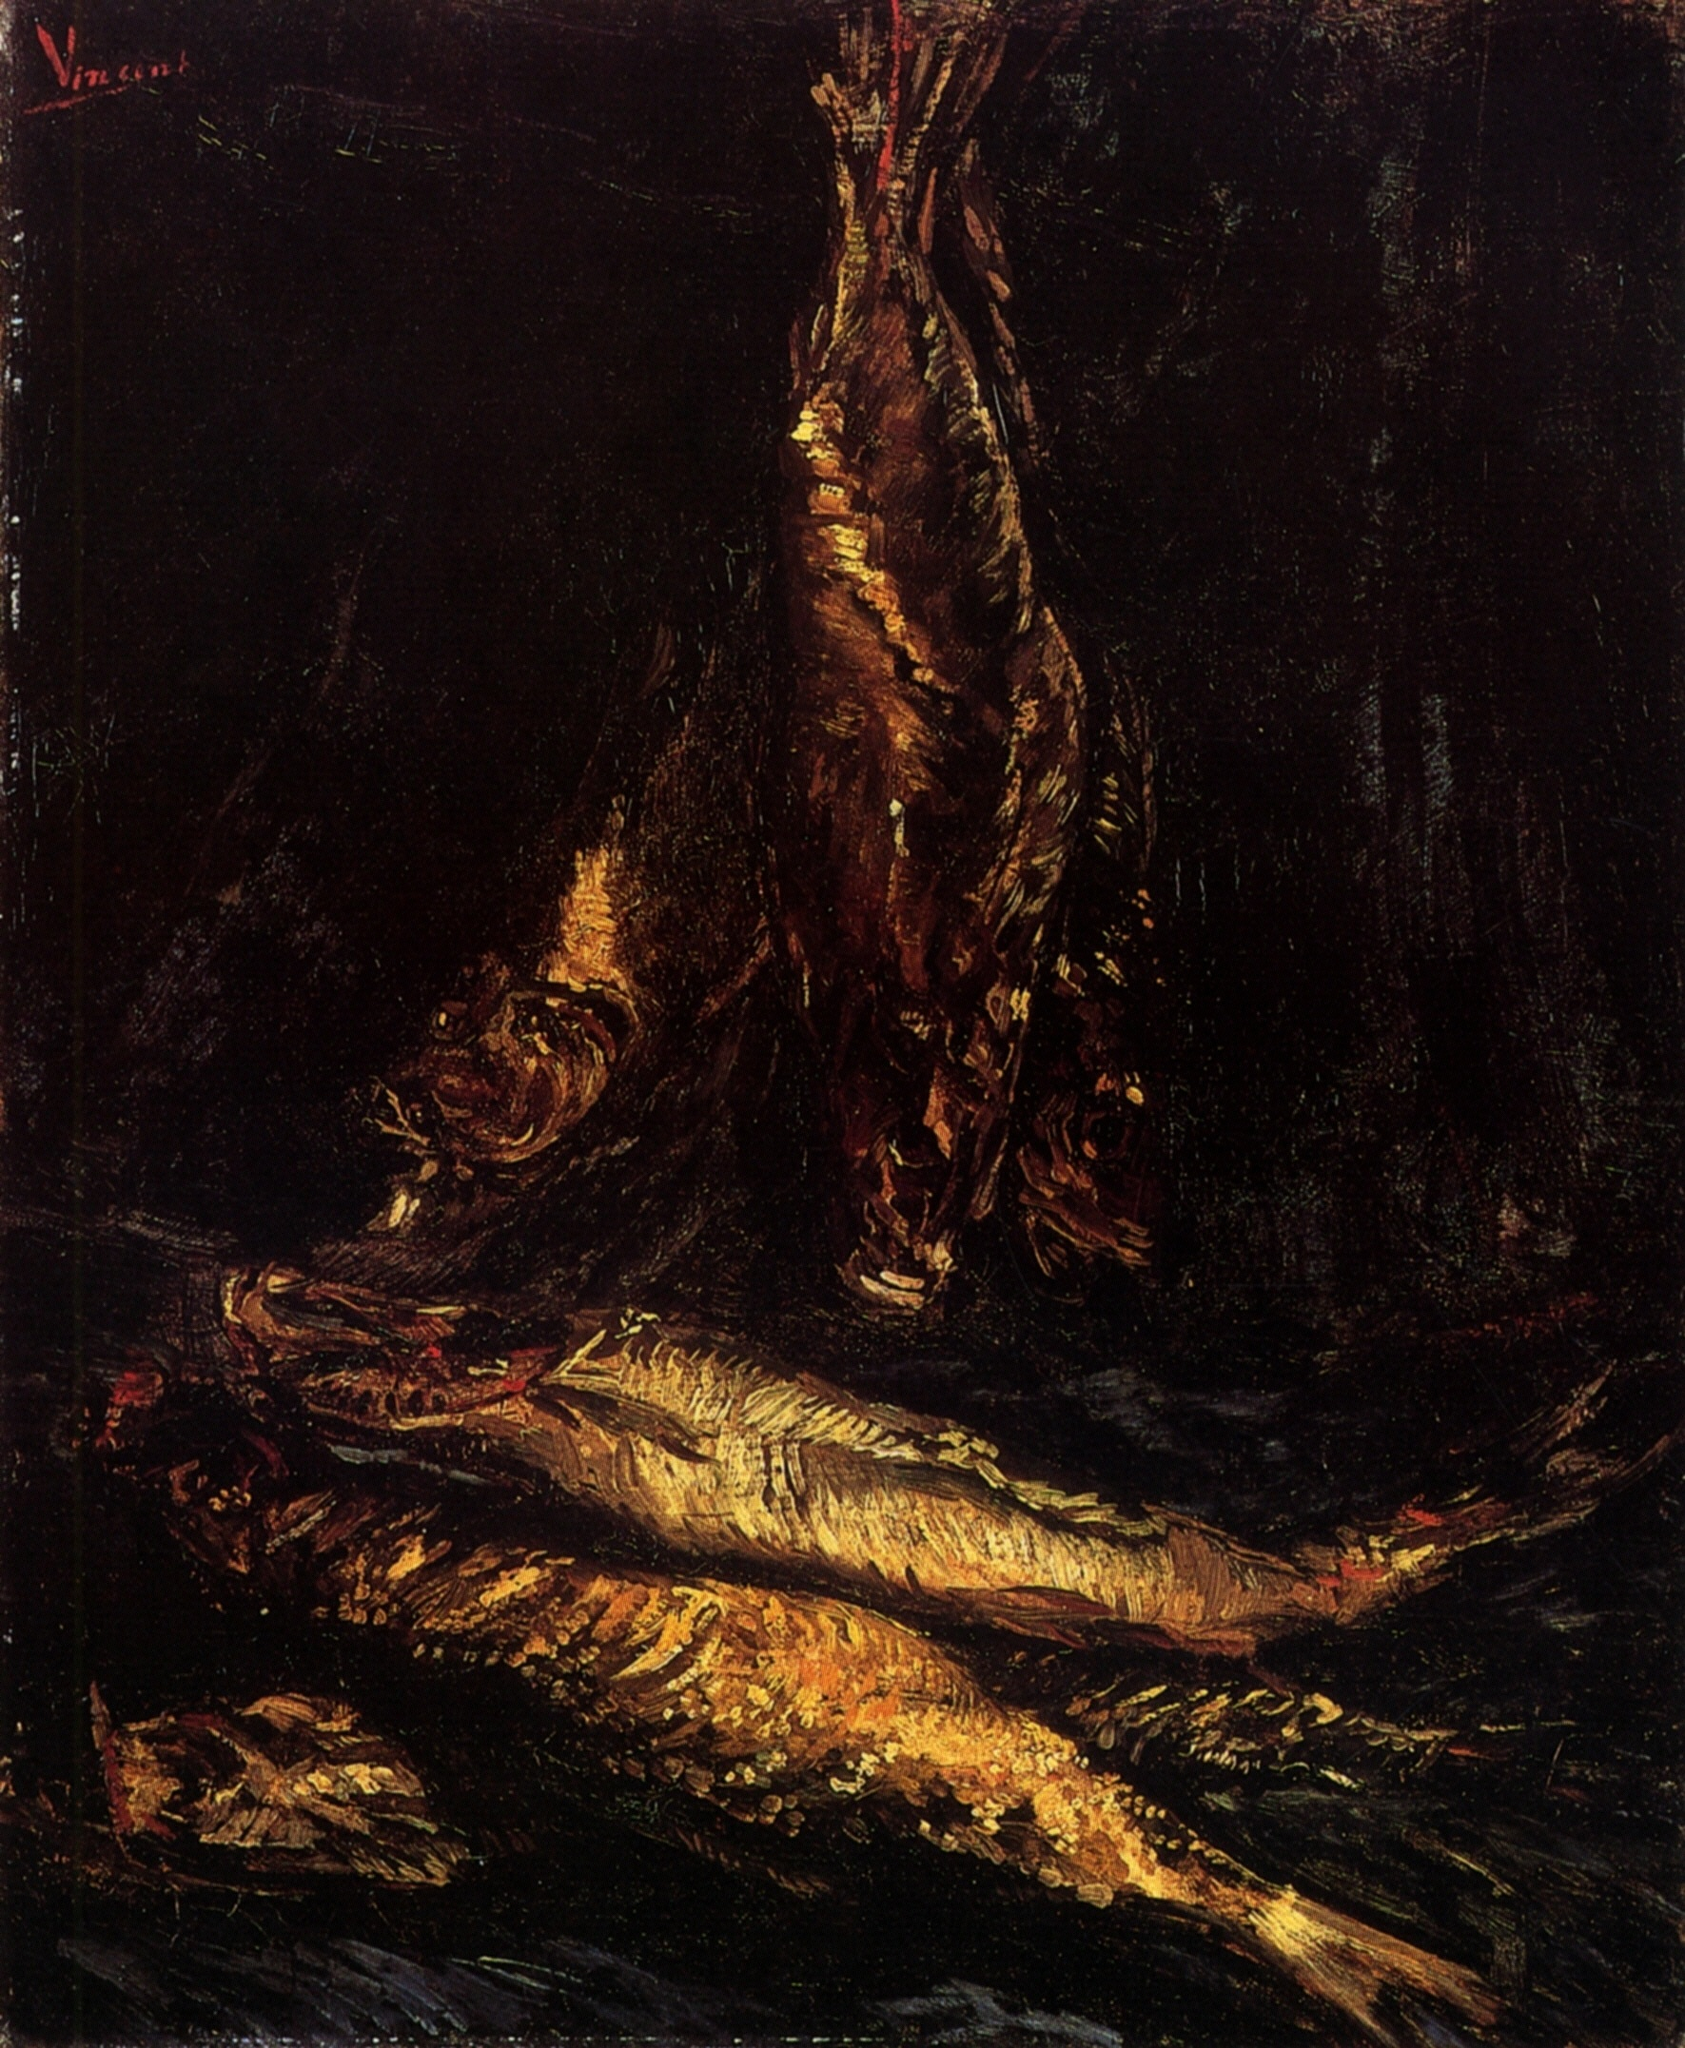Explain the visual content of the image in great detail. The image is a striking depiction of a fish still life, likely painted in a post-impressionist style, commonly associated with artists like Vincent van Gogh. The artwork captures three fish, with one prominently hanging vertically by its tail. This arrangement and the loose, expressive brushstrokes give it a dynamic and somewhat abstract appearance. The background is deeply shadowed, directing the viewer's focus primarily on the shimmering textures and details of the fish's scales, which are rendered in golden and reddish-brown hues. The visceral realism of the subject contrasts sharply with the dark, almost formless background, highlighting the naturalistic details and the physical presence of the fish. 